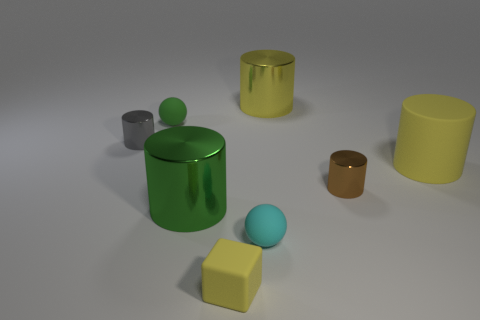Subtract all rubber cylinders. How many cylinders are left? 4 Subtract all green cylinders. How many cylinders are left? 4 Subtract all cyan cylinders. Subtract all gray spheres. How many cylinders are left? 5 Add 1 small rubber cubes. How many objects exist? 9 Subtract all blocks. How many objects are left? 7 Subtract all cyan balls. Subtract all blue cylinders. How many objects are left? 7 Add 4 green rubber objects. How many green rubber objects are left? 5 Add 5 tiny cylinders. How many tiny cylinders exist? 7 Subtract 0 purple cylinders. How many objects are left? 8 